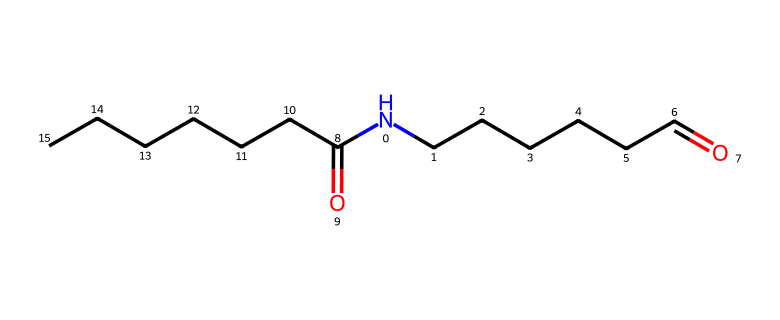What is the molecular formula of this polymer? By analyzing the SMILES representation, we can count the number of carbon (C), hydrogen (H), oxygen (O), and nitrogen (N) atoms present. The breakdown shows there are 18 carbons, 35 hydrogens, 2 oxygens, and 1 nitrogen, leading to the molecular formula C18H35N2O2.
Answer: C18H35N2O2 How many carbon atoms are in the structure? In the SMILES notation, we identify each carbon by counting the 'C' characters, including those in the chain and branches. Counting gives us a total of 18 carbon atoms.
Answer: 18 What functional groups are present in this polymer? The SMILES representation includes the carboxylic acid functional groups (indicated by the presence of =O and -OH that bond with carbon), as well as an amine group (indicated by the 'N' connected to carbon chains).
Answer: carboxylic acid, amine What is the longest carbon chain in this polymer? The longest continuous chain of carbon atoms can be traced through the structure. Examining the depicted chain in the SMILES shows a linear arrangement of 12 carbon atoms in the primary chain.
Answer: 12 What type of polymer is represented in this structure? Based on the functional groups and structure of the molecule, which exhibits both ester and amide characteristics, this polymer is classified as a polyamide.
Answer: polyamide How many nitrogen atoms are present in the polymer? In the SMILES, we can identify nitrogen atoms by counting the 'N' characters. There is 1 nitrogen present in the structure.
Answer: 1 What characteristic does this polymer impart to vintage clothing? The presence of both amine and acid functional groups suggests that the polymer likely contributes to durability and elasticity in synthetic fabrics, which was a key feature of early synthetic clothing.
Answer: durability, elasticity 